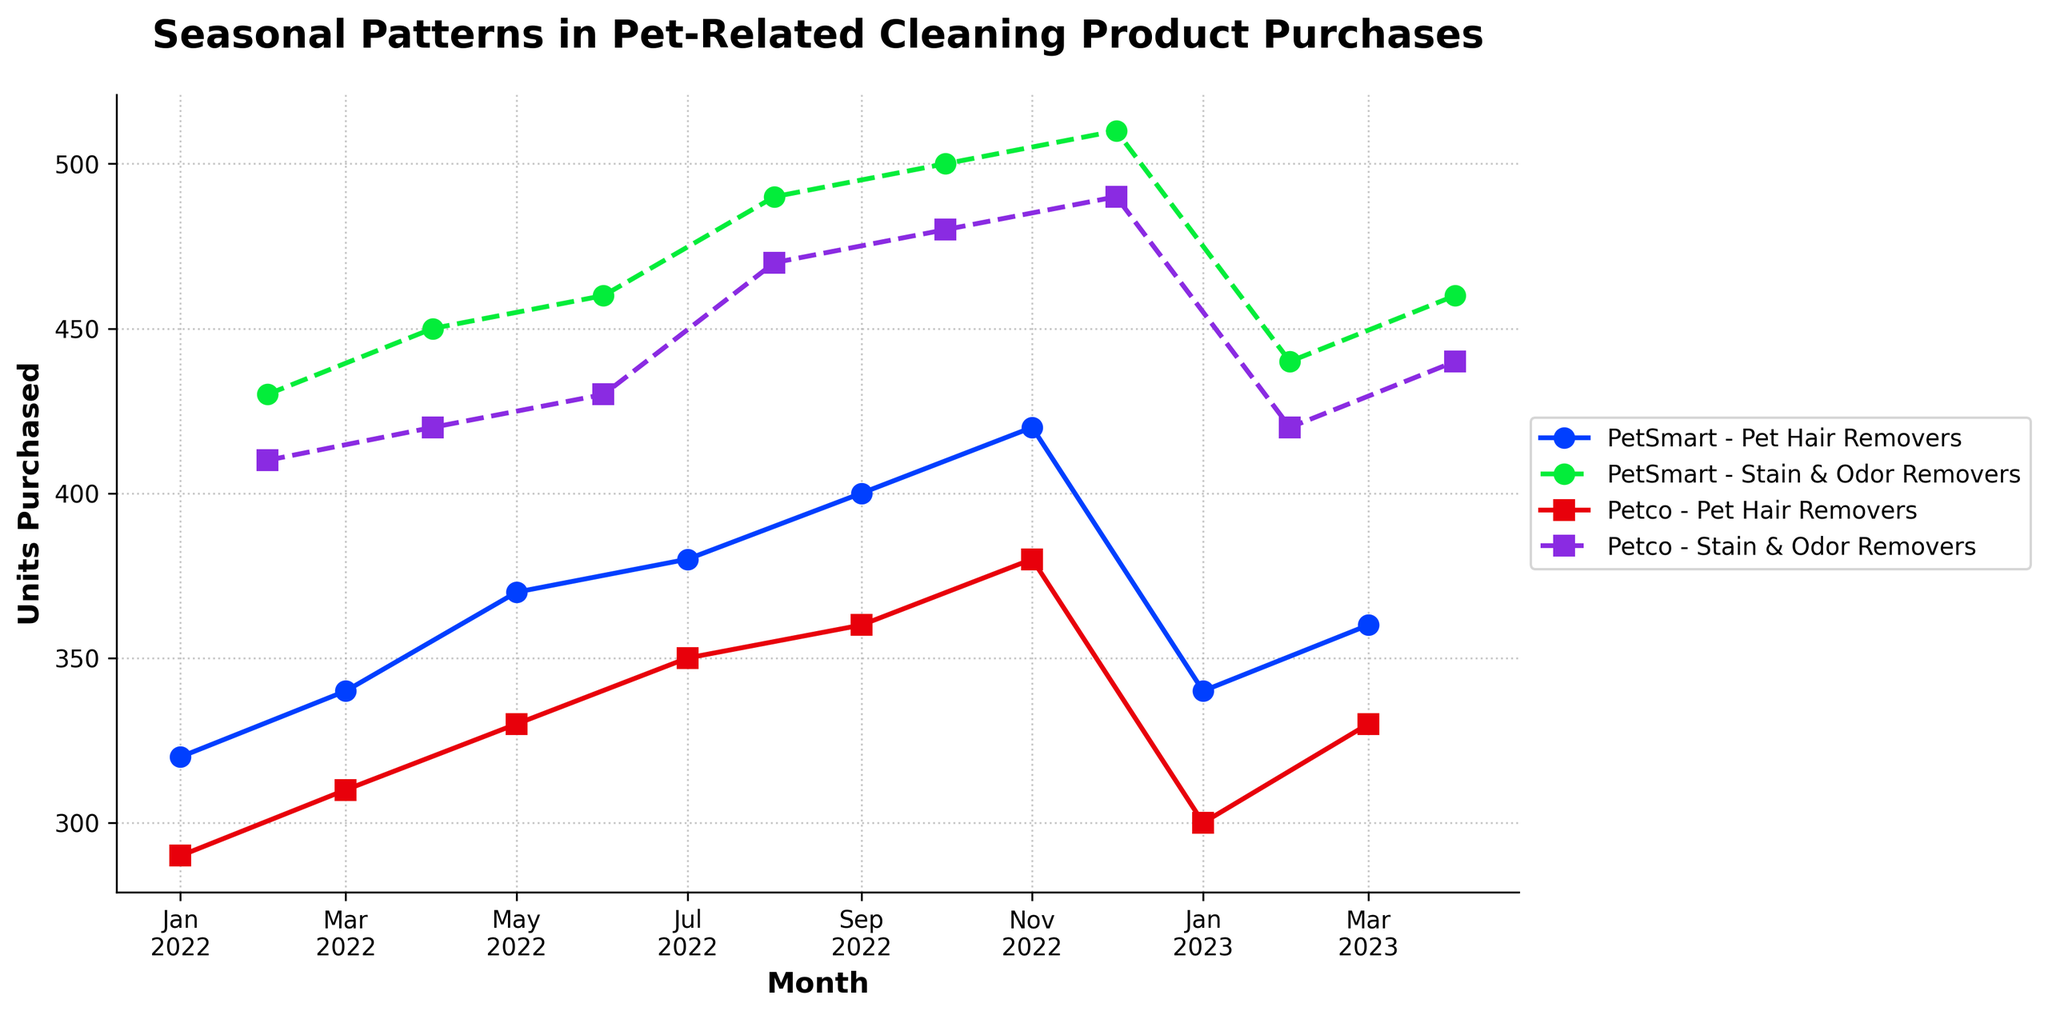Which month had the highest units purchased for Stain & Odor Removers at PetSmart? By examining the different points on the graph corresponding to Stain & Odor Removers at PetSmart, we find that December 2022 has the highest units purchased of 510.
Answer: December 2022 How do the units purchased of Pet Hair Removers in January 2023 at PetSmart compare to January 2022? By looking at the respective points on the graph for Pet Hair Removers at PetSmart, in January 2022, there were 320 units purchased; in January 2023, there were 340 units purchased. Thus, there was an increase.
Answer: An increase What is the average number of units purchased for Pet Hair Removers at PetSmart over the entire period? Sum the units purchased for Pet Hair Removers at PetSmart across all months and divide by the number of months data is available. The sum from the data is 3,210 units over 9 months (320+340+370+380+400+420+340+360) = 2,930/9 ≈ 356 units.
Answer: 356 units Which product and store had the least units purchased in March 2022? Identify the points on the graph for all stores and products in March 2022. Pet Hair Removers at Petco had 310 units purchased, which is the lowest compared to others.
Answer: Pet Hair Removers at Petco Is there a visible pattern or trend for the units purchased of Stain & Odor Removers at Petco throughout the year? By looking at the graph for Stain & Odor Removers at Petco, there's a noticeable upward trend from February 2022 to December 2022, peaking in December. After that, in early 2023, values slightly decline but stay relatively high.
Answer: Upward trend with a slight decline in early 2023 How do the average units purchased for Pet Hair Removers at Petco compare between 2022 and 2023? Calculate the average units purchased for Pet Hair Removers at Petco for each year. For 2022: (290 + 310 + 330 + 350 + 360 + 380 + 300) / 7 = 2320/7 ≈ 331. For 2023: (300 + 330) / 2 = 630/2 = 315. Compare the two averages: 331 vs 315.
Answer: Higher in 2022 What is the difference in units purchased of Stain & Odor Removers between August 2022 and October 2022 at PetSmart? Locate the units purchased for Stain & Odor Removers at PetSmart in August 2022 (490 units) and October 2022 (500 units). The difference is 500 - 490 = 10 units.
Answer: 10 units Which month saw the highest combined units purchased for both product categories at both stores? By examining the total units purchased for both categories and stores for each month, December 2022 has the highest combined units: PetSmart Stain & Odor Removers (510) + Petco Stain & Odor Removers (490) + PetSmart Pet Hair Removers (not applicable) + Petco Pet Hair Removers (not applicable).
Answer: December 2022 Overall, which store sold more units of Stain & Odor Removers during the period measured? Sum the units purchased for Stain & Odor Removers for each store. PetSmart: 430+450+460+490+500+510+440+460=3,240 units. Petco: 410+420+430+470+480+490+420+440=3,060 units. PetSmart has higher total units.
Answer: PetSmart 